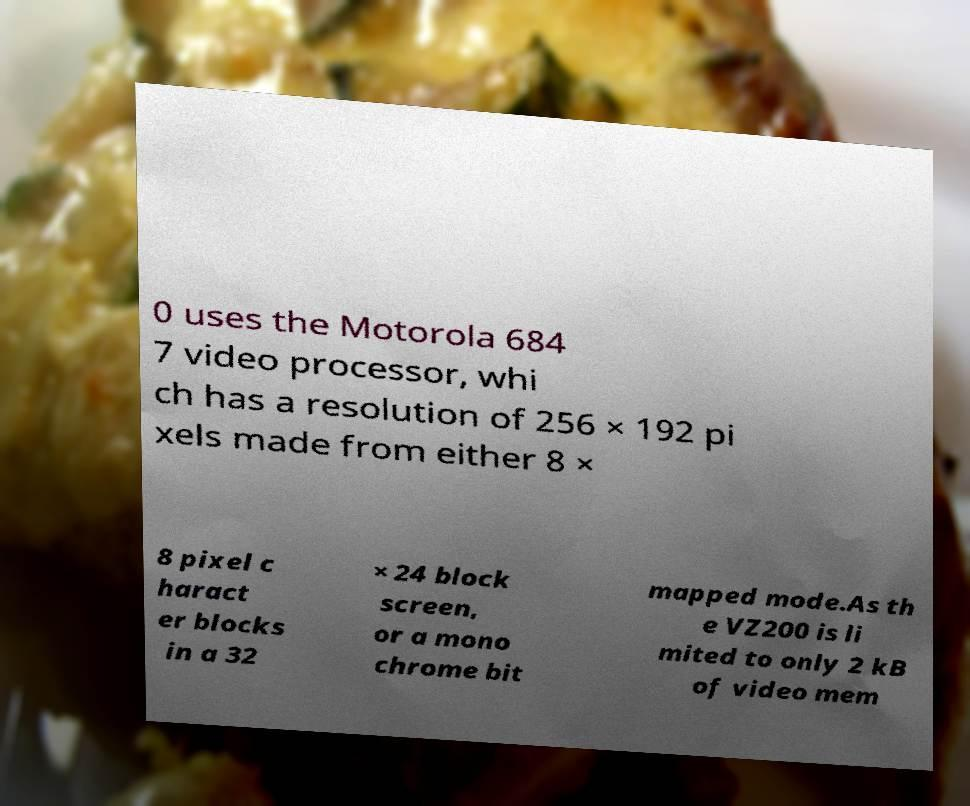Can you accurately transcribe the text from the provided image for me? 0 uses the Motorola 684 7 video processor, whi ch has a resolution of 256 × 192 pi xels made from either 8 × 8 pixel c haract er blocks in a 32 × 24 block screen, or a mono chrome bit mapped mode.As th e VZ200 is li mited to only 2 kB of video mem 